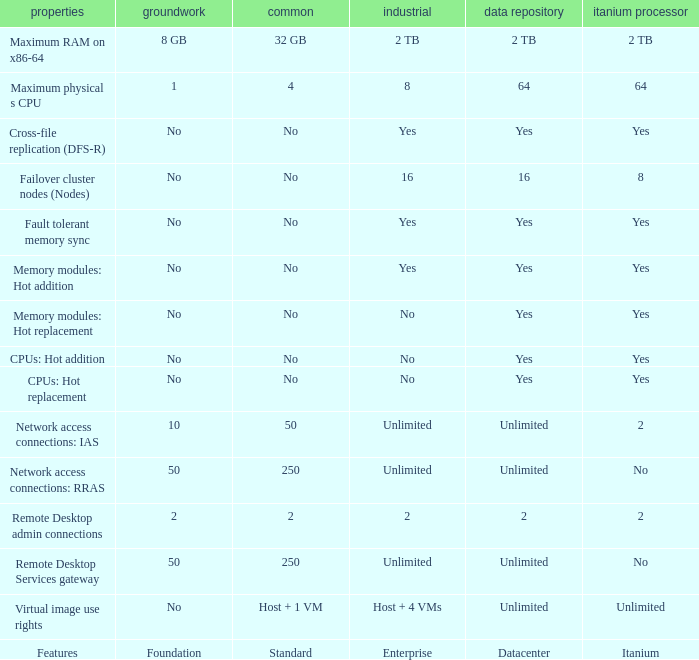Could you parse the entire table as a dict? {'header': ['properties', 'groundwork', 'common', 'industrial', 'data repository', 'itanium processor'], 'rows': [['Maximum RAM on x86-64', '8 GB', '32 GB', '2 TB', '2 TB', '2 TB'], ['Maximum physical s CPU', '1', '4', '8', '64', '64'], ['Cross-file replication (DFS-R)', 'No', 'No', 'Yes', 'Yes', 'Yes'], ['Failover cluster nodes (Nodes)', 'No', 'No', '16', '16', '8'], ['Fault tolerant memory sync', 'No', 'No', 'Yes', 'Yes', 'Yes'], ['Memory modules: Hot addition', 'No', 'No', 'Yes', 'Yes', 'Yes'], ['Memory modules: Hot replacement', 'No', 'No', 'No', 'Yes', 'Yes'], ['CPUs: Hot addition', 'No', 'No', 'No', 'Yes', 'Yes'], ['CPUs: Hot replacement', 'No', 'No', 'No', 'Yes', 'Yes'], ['Network access connections: IAS', '10', '50', 'Unlimited', 'Unlimited', '2'], ['Network access connections: RRAS', '50', '250', 'Unlimited', 'Unlimited', 'No'], ['Remote Desktop admin connections', '2', '2', '2', '2', '2'], ['Remote Desktop Services gateway', '50', '250', 'Unlimited', 'Unlimited', 'No'], ['Virtual image use rights', 'No', 'Host + 1 VM', 'Host + 4 VMs', 'Unlimited', 'Unlimited'], ['Features', 'Foundation', 'Standard', 'Enterprise', 'Datacenter', 'Itanium']]} What datacenter is specified for the network access connections: rras feature? Unlimited. 